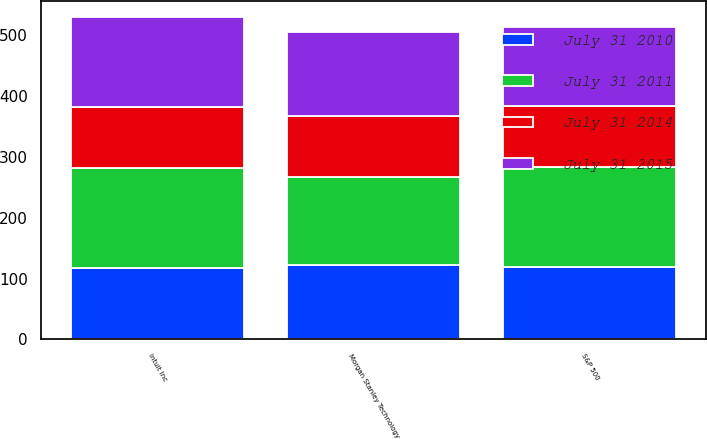Convert chart. <chart><loc_0><loc_0><loc_500><loc_500><stacked_bar_chart><ecel><fcel>Intuit Inc<fcel>S&P 500<fcel>Morgan Stanley Technology<nl><fcel>July 31 2014<fcel>100<fcel>100<fcel>100<nl><fcel>July 31 2010<fcel>117.48<fcel>119.65<fcel>122.62<nl><fcel>July 31 2015<fcel>147.59<fcel>130.58<fcel>136.46<nl><fcel>July 31 2011<fcel>164.38<fcel>163.22<fcel>144.66<nl></chart> 